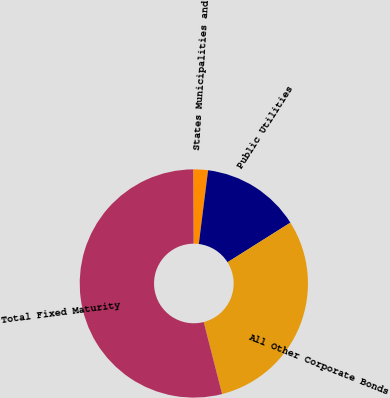Convert chart to OTSL. <chart><loc_0><loc_0><loc_500><loc_500><pie_chart><fcel>States Municipalities and<fcel>Public Utilities<fcel>All Other Corporate Bonds<fcel>Total Fixed Maturity<nl><fcel>2.08%<fcel>14.06%<fcel>29.96%<fcel>53.9%<nl></chart> 